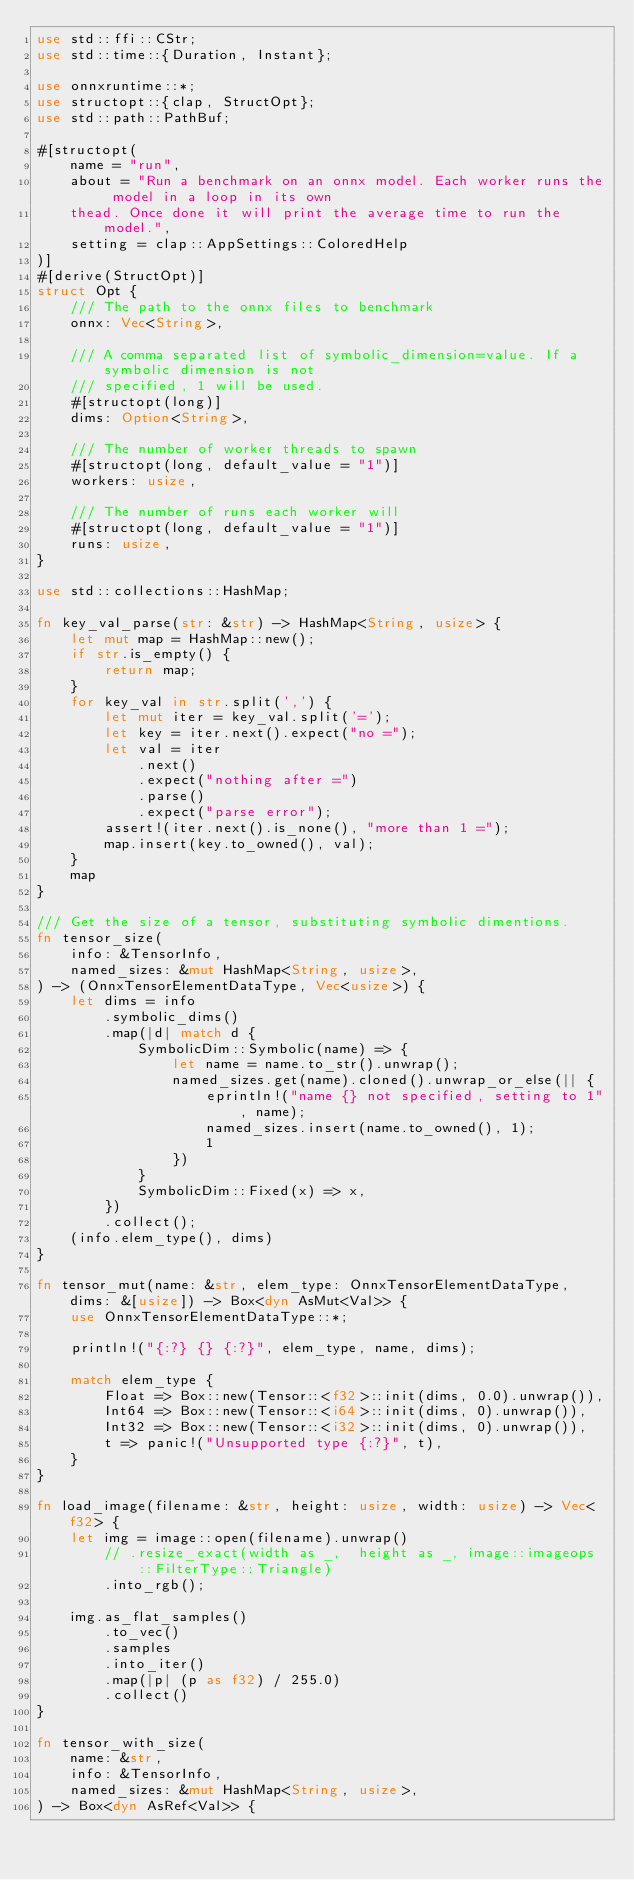<code> <loc_0><loc_0><loc_500><loc_500><_Rust_>use std::ffi::CStr;
use std::time::{Duration, Instant};

use onnxruntime::*;
use structopt::{clap, StructOpt};
use std::path::PathBuf;

#[structopt(
    name = "run",
    about = "Run a benchmark on an onnx model. Each worker runs the model in a loop in its own
    thead. Once done it will print the average time to run the model.",
    setting = clap::AppSettings::ColoredHelp
)]
#[derive(StructOpt)]
struct Opt {
    /// The path to the onnx files to benchmark
    onnx: Vec<String>,

    /// A comma separated list of symbolic_dimension=value. If a symbolic dimension is not
    /// specified, 1 will be used.
    #[structopt(long)]
    dims: Option<String>,

    /// The number of worker threads to spawn
    #[structopt(long, default_value = "1")]
    workers: usize,

    /// The number of runs each worker will
    #[structopt(long, default_value = "1")]
    runs: usize,
}

use std::collections::HashMap;

fn key_val_parse(str: &str) -> HashMap<String, usize> {
    let mut map = HashMap::new();
    if str.is_empty() {
        return map;
    }
    for key_val in str.split(',') {
        let mut iter = key_val.split('=');
        let key = iter.next().expect("no =");
        let val = iter
            .next()
            .expect("nothing after =")
            .parse()
            .expect("parse error");
        assert!(iter.next().is_none(), "more than 1 =");
        map.insert(key.to_owned(), val);
    }
    map
}

/// Get the size of a tensor, substituting symbolic dimentions.
fn tensor_size(
    info: &TensorInfo,
    named_sizes: &mut HashMap<String, usize>,
) -> (OnnxTensorElementDataType, Vec<usize>) {
    let dims = info
        .symbolic_dims()
        .map(|d| match d {
            SymbolicDim::Symbolic(name) => {
                let name = name.to_str().unwrap();
                named_sizes.get(name).cloned().unwrap_or_else(|| {
                    eprintln!("name {} not specified, setting to 1", name);
                    named_sizes.insert(name.to_owned(), 1);
                    1
                })
            }
            SymbolicDim::Fixed(x) => x,
        })
        .collect();
    (info.elem_type(), dims)
}

fn tensor_mut(name: &str, elem_type: OnnxTensorElementDataType, dims: &[usize]) -> Box<dyn AsMut<Val>> {
    use OnnxTensorElementDataType::*;
    
    println!("{:?} {} {:?}", elem_type, name, dims);

    match elem_type {
        Float => Box::new(Tensor::<f32>::init(dims, 0.0).unwrap()),
        Int64 => Box::new(Tensor::<i64>::init(dims, 0).unwrap()),
        Int32 => Box::new(Tensor::<i32>::init(dims, 0).unwrap()),
        t => panic!("Unsupported type {:?}", t),
    }
}

fn load_image(filename: &str, height: usize, width: usize) -> Vec<f32> {
    let img = image::open(filename).unwrap()
        // .resize_exact(width as _,  height as _, image::imageops::FilterType::Triangle)
        .into_rgb();

    img.as_flat_samples()
        .to_vec()
        .samples
        .into_iter()
        .map(|p| (p as f32) / 255.0)
        .collect()
}

fn tensor_with_size(
    name: &str,
    info: &TensorInfo,
    named_sizes: &mut HashMap<String, usize>,
) -> Box<dyn AsRef<Val>> {</code> 